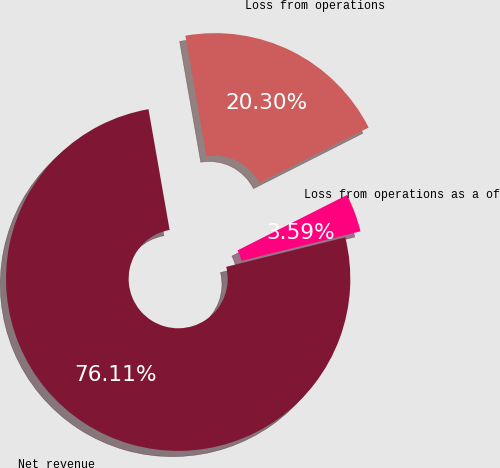Convert chart to OTSL. <chart><loc_0><loc_0><loc_500><loc_500><pie_chart><fcel>Net revenue<fcel>Loss from operations<fcel>Loss from operations as a of<nl><fcel>76.11%<fcel>20.3%<fcel>3.59%<nl></chart> 